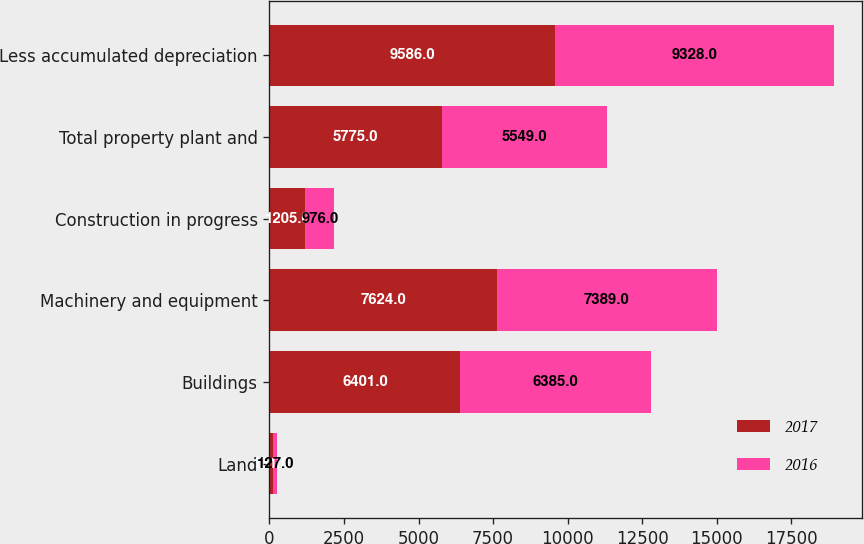Convert chart to OTSL. <chart><loc_0><loc_0><loc_500><loc_500><stacked_bar_chart><ecel><fcel>Land<fcel>Buildings<fcel>Machinery and equipment<fcel>Construction in progress<fcel>Total property plant and<fcel>Less accumulated depreciation<nl><fcel>2017<fcel>131<fcel>6401<fcel>7624<fcel>1205<fcel>5775<fcel>9586<nl><fcel>2016<fcel>127<fcel>6385<fcel>7389<fcel>976<fcel>5549<fcel>9328<nl></chart> 